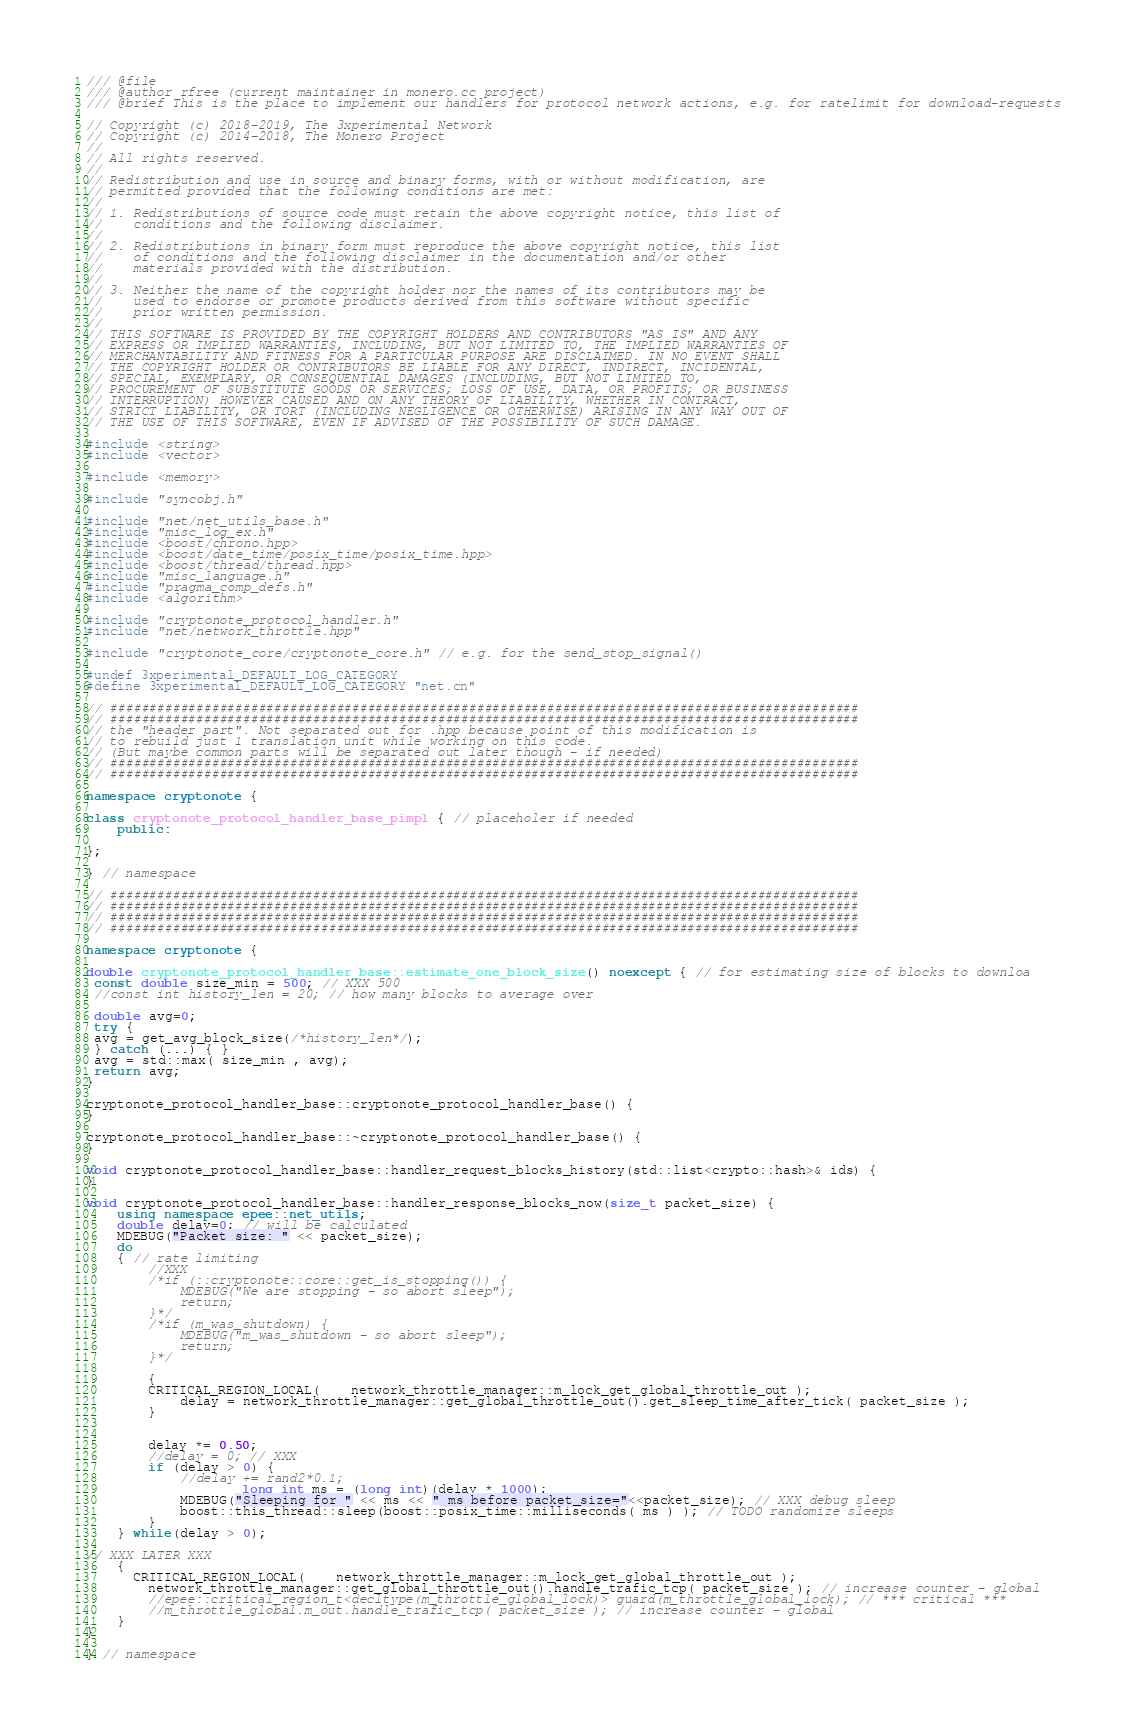Convert code to text. <code><loc_0><loc_0><loc_500><loc_500><_C++_>/// @file
/// @author rfree (current maintainer in monero.cc project)
/// @brief This is the place to implement our handlers for protocol network actions, e.g. for ratelimit for download-requests

// Copyright (c) 2018-2019, The 3xperimental Network
// Copyright (c) 2014-2018, The Monero Project
//
// All rights reserved.
//
// Redistribution and use in source and binary forms, with or without modification, are
// permitted provided that the following conditions are met:
//
// 1. Redistributions of source code must retain the above copyright notice, this list of
//    conditions and the following disclaimer.
//
// 2. Redistributions in binary form must reproduce the above copyright notice, this list
//    of conditions and the following disclaimer in the documentation and/or other
//    materials provided with the distribution.
//
// 3. Neither the name of the copyright holder nor the names of its contributors may be
//    used to endorse or promote products derived from this software without specific
//    prior written permission.
//
// THIS SOFTWARE IS PROVIDED BY THE COPYRIGHT HOLDERS AND CONTRIBUTORS "AS IS" AND ANY
// EXPRESS OR IMPLIED WARRANTIES, INCLUDING, BUT NOT LIMITED TO, THE IMPLIED WARRANTIES OF
// MERCHANTABILITY AND FITNESS FOR A PARTICULAR PURPOSE ARE DISCLAIMED. IN NO EVENT SHALL
// THE COPYRIGHT HOLDER OR CONTRIBUTORS BE LIABLE FOR ANY DIRECT, INDIRECT, INCIDENTAL,
// SPECIAL, EXEMPLARY, OR CONSEQUENTIAL DAMAGES (INCLUDING, BUT NOT LIMITED TO,
// PROCUREMENT OF SUBSTITUTE GOODS OR SERVICES; LOSS OF USE, DATA, OR PROFITS; OR BUSINESS
// INTERRUPTION) HOWEVER CAUSED AND ON ANY THEORY OF LIABILITY, WHETHER IN CONTRACT,
// STRICT LIABILITY, OR TORT (INCLUDING NEGLIGENCE OR OTHERWISE) ARISING IN ANY WAY OUT OF
// THE USE OF THIS SOFTWARE, EVEN IF ADVISED OF THE POSSIBILITY OF SUCH DAMAGE.

#include <string>
#include <vector>

#include <memory>

#include "syncobj.h"

#include "net/net_utils_base.h"
#include "misc_log_ex.h"
#include <boost/chrono.hpp>
#include <boost/date_time/posix_time/posix_time.hpp>
#include <boost/thread/thread.hpp>
#include "misc_language.h"
#include "pragma_comp_defs.h"
#include <algorithm>

#include "cryptonote_protocol_handler.h"
#include "net/network_throttle.hpp"

#include "cryptonote_core/cryptonote_core.h" // e.g. for the send_stop_signal()

#undef 3xperimental_DEFAULT_LOG_CATEGORY
#define 3xperimental_DEFAULT_LOG_CATEGORY "net.cn"

// ################################################################################################
// ################################################################################################
// the "header part". Not separated out for .hpp because point of this modification is
// to rebuild just 1 translation unit while working on this code.
// (But maybe common parts will be separated out later though - if needed)
// ################################################################################################
// ################################################################################################

namespace cryptonote {

class cryptonote_protocol_handler_base_pimpl { // placeholer if needed
	public:

};

} // namespace

// ################################################################################################
// ################################################################################################
// ################################################################################################
// ################################################################################################

namespace cryptonote {

double cryptonote_protocol_handler_base::estimate_one_block_size() noexcept { // for estimating size of blocks to downloa
 const double size_min = 500; // XXX 500
 //const int history_len = 20; // how many blocks to average over

 double avg=0;
 try {
 avg = get_avg_block_size(/*history_len*/);
 } catch (...) { }
 avg = std::max( size_min , avg);
 return avg;
}

cryptonote_protocol_handler_base::cryptonote_protocol_handler_base() {
}

cryptonote_protocol_handler_base::~cryptonote_protocol_handler_base() {
}

void cryptonote_protocol_handler_base::handler_request_blocks_history(std::list<crypto::hash>& ids) {
}

void cryptonote_protocol_handler_base::handler_response_blocks_now(size_t packet_size) {
	using namespace epee::net_utils;
	double delay=0; // will be calculated
	MDEBUG("Packet size: " << packet_size);
	do
	{ // rate limiting
		//XXX
		/*if (::cryptonote::core::get_is_stopping()) {
			MDEBUG("We are stopping - so abort sleep");
			return;
		}*/
		/*if (m_was_shutdown) {
			MDEBUG("m_was_shutdown - so abort sleep");
			return;
		}*/

		{
	  	CRITICAL_REGION_LOCAL(	network_throttle_manager::m_lock_get_global_throttle_out );
			delay = network_throttle_manager::get_global_throttle_out().get_sleep_time_after_tick( packet_size );
		}


		delay *= 0.50;
		//delay = 0; // XXX
		if (delay > 0) {
			//delay += rand2*0.1;
            		long int ms = (long int)(delay * 1000);
			MDEBUG("Sleeping for " << ms << " ms before packet_size="<<packet_size); // XXX debug sleep
			boost::this_thread::sleep(boost::posix_time::milliseconds( ms ) ); // TODO randomize sleeps
		}
	} while(delay > 0);

// XXX LATER XXX
	{
	  CRITICAL_REGION_LOCAL(	network_throttle_manager::m_lock_get_global_throttle_out );
		network_throttle_manager::get_global_throttle_out().handle_trafic_tcp( packet_size ); // increase counter - global
		//epee::critical_region_t<decltype(m_throttle_global_lock)> guard(m_throttle_global_lock); // *** critical ***
		//m_throttle_global.m_out.handle_trafic_tcp( packet_size ); // increase counter - global
	}
}

} // namespace
</code> 